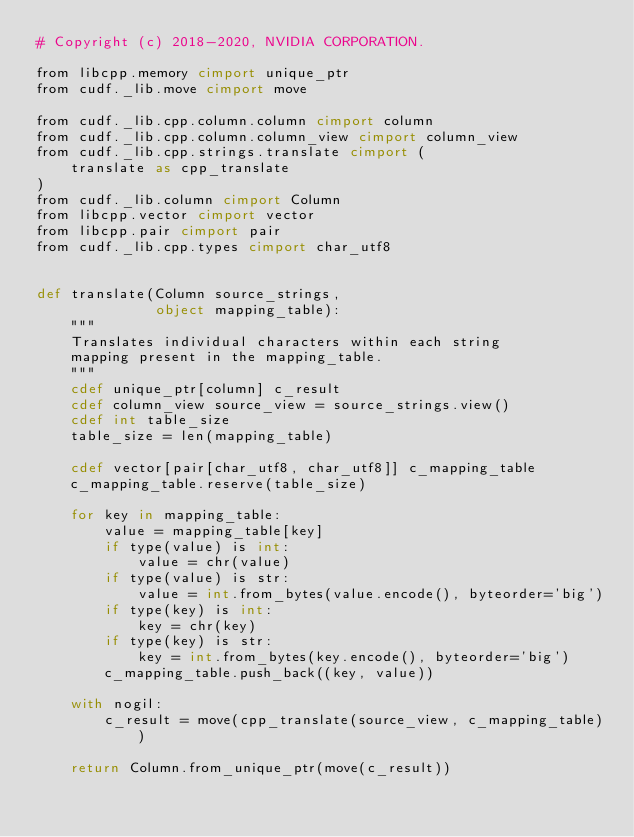Convert code to text. <code><loc_0><loc_0><loc_500><loc_500><_Cython_># Copyright (c) 2018-2020, NVIDIA CORPORATION.

from libcpp.memory cimport unique_ptr
from cudf._lib.move cimport move

from cudf._lib.cpp.column.column cimport column
from cudf._lib.cpp.column.column_view cimport column_view
from cudf._lib.cpp.strings.translate cimport (
    translate as cpp_translate
)
from cudf._lib.column cimport Column
from libcpp.vector cimport vector
from libcpp.pair cimport pair
from cudf._lib.cpp.types cimport char_utf8


def translate(Column source_strings,
              object mapping_table):
    """
    Translates individual characters within each string
    mapping present in the mapping_table.
    """
    cdef unique_ptr[column] c_result
    cdef column_view source_view = source_strings.view()
    cdef int table_size
    table_size = len(mapping_table)

    cdef vector[pair[char_utf8, char_utf8]] c_mapping_table
    c_mapping_table.reserve(table_size)

    for key in mapping_table:
        value = mapping_table[key]
        if type(value) is int:
            value = chr(value)
        if type(value) is str:
            value = int.from_bytes(value.encode(), byteorder='big')
        if type(key) is int:
            key = chr(key)
        if type(key) is str:
            key = int.from_bytes(key.encode(), byteorder='big')
        c_mapping_table.push_back((key, value))

    with nogil:
        c_result = move(cpp_translate(source_view, c_mapping_table))

    return Column.from_unique_ptr(move(c_result))
</code> 